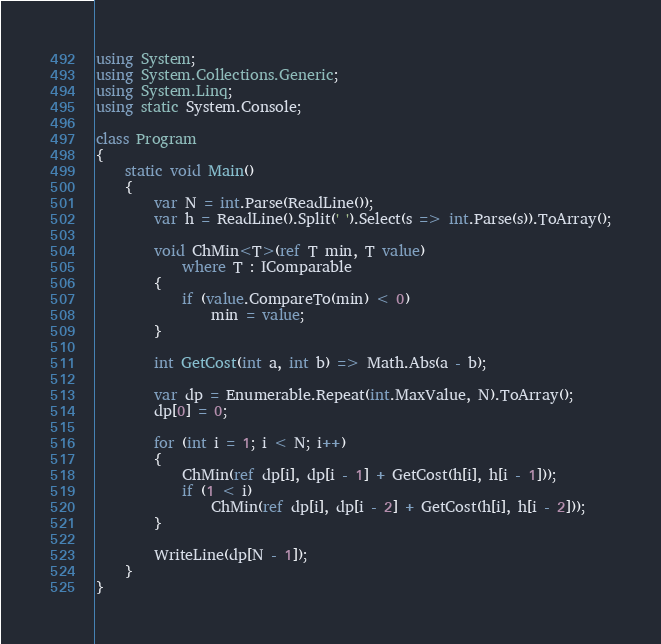Convert code to text. <code><loc_0><loc_0><loc_500><loc_500><_C#_>using System;
using System.Collections.Generic;
using System.Linq;
using static System.Console;

class Program
{
    static void Main()
    {
        var N = int.Parse(ReadLine());
        var h = ReadLine().Split(' ').Select(s => int.Parse(s)).ToArray();

        void ChMin<T>(ref T min, T value)
            where T : IComparable
        {
            if (value.CompareTo(min) < 0)
                min = value;
        }
        
        int GetCost(int a, int b) => Math.Abs(a - b);

        var dp = Enumerable.Repeat(int.MaxValue, N).ToArray();
        dp[0] = 0;

        for (int i = 1; i < N; i++)
        {
            ChMin(ref dp[i], dp[i - 1] + GetCost(h[i], h[i - 1]));
            if (1 < i)
                ChMin(ref dp[i], dp[i - 2] + GetCost(h[i], h[i - 2]));
        }

        WriteLine(dp[N - 1]);
    }
}
</code> 